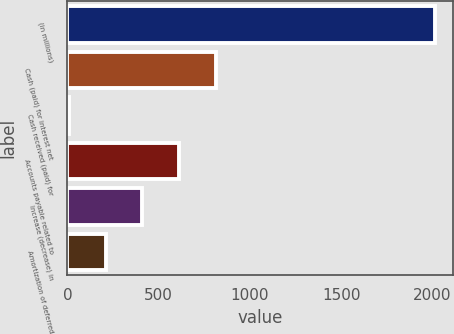<chart> <loc_0><loc_0><loc_500><loc_500><bar_chart><fcel>(in millions)<fcel>Cash (paid) for interest net<fcel>Cash received (paid) for<fcel>Accounts payable related to<fcel>Increase (decrease) in<fcel>Amortization of deferred<nl><fcel>2015<fcel>811.58<fcel>9.3<fcel>611.01<fcel>410.44<fcel>209.87<nl></chart> 